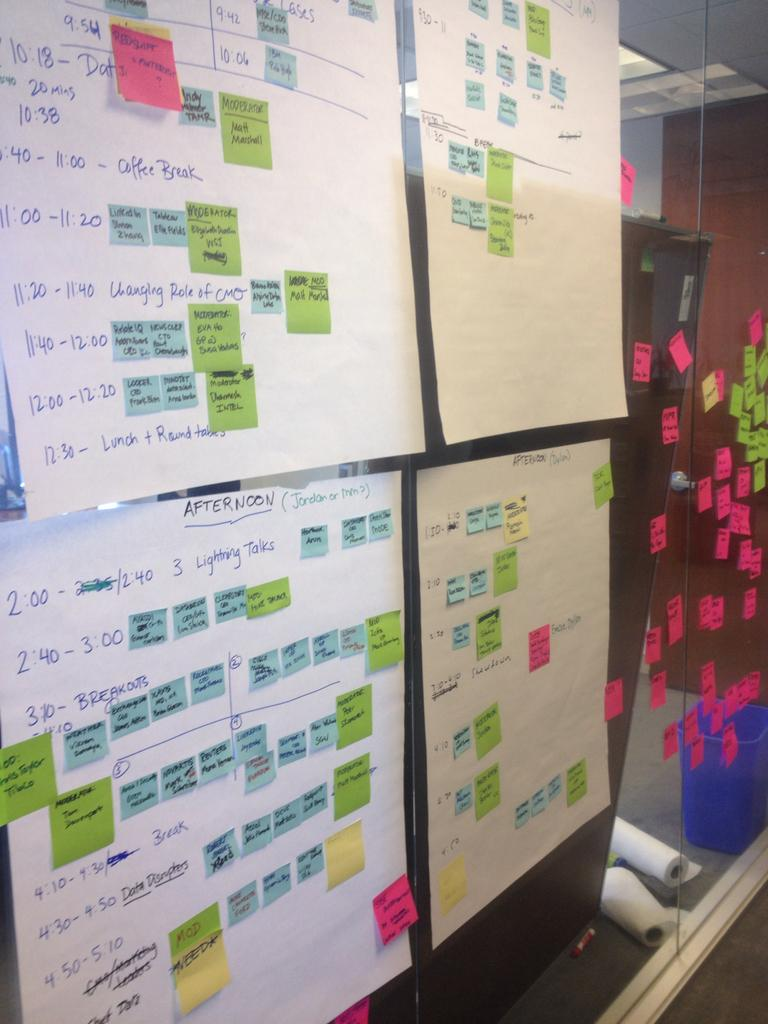What is placed on the glass in the image? Papers and stickers are placed on the glass. What type of container is present in the image? There is a bin in the image. What type of stationery items can be seen in the image? There are paper rolls in the image. What type of illumination is visible in the image? There are lights visible in the image. What can be seen through the glass, although partially? The view through the glass is partially visible. What type of throat condition can be seen in the image? There is no throat condition present in the image. What type of coastline is visible in the image? There is no coastline visible in the image. 